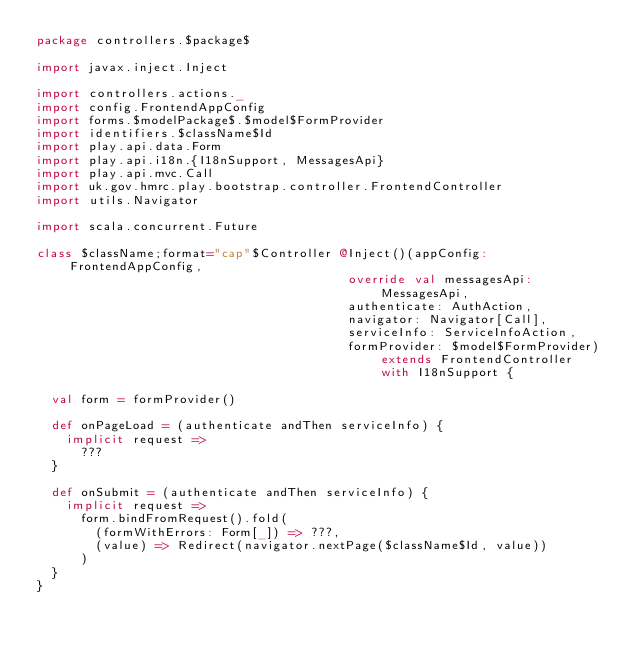Convert code to text. <code><loc_0><loc_0><loc_500><loc_500><_Scala_>package controllers.$package$

import javax.inject.Inject

import controllers.actions._
import config.FrontendAppConfig
import forms.$modelPackage$.$model$FormProvider
import identifiers.$className$Id
import play.api.data.Form
import play.api.i18n.{I18nSupport, MessagesApi}
import play.api.mvc.Call
import uk.gov.hmrc.play.bootstrap.controller.FrontendController
import utils.Navigator

import scala.concurrent.Future

class $className;format="cap"$Controller @Inject()(appConfig: FrontendAppConfig,
                                          override val messagesApi: MessagesApi,
                                          authenticate: AuthAction,
                                          navigator: Navigator[Call],
                                          serviceInfo: ServiceInfoAction,
                                          formProvider: $model$FormProvider) extends FrontendController with I18nSupport {

  val form = formProvider()

  def onPageLoad = (authenticate andThen serviceInfo) {
    implicit request =>
      ???
  }

  def onSubmit = (authenticate andThen serviceInfo) {
    implicit request =>
      form.bindFromRequest().fold(
        (formWithErrors: Form[_]) => ???,
        (value) => Redirect(navigator.nextPage($className$Id, value))
      )
  }
}
</code> 